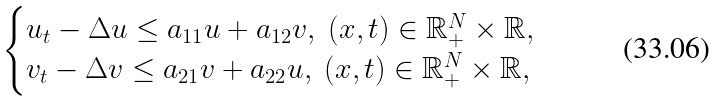Convert formula to latex. <formula><loc_0><loc_0><loc_500><loc_500>\begin{cases} u _ { t } - \Delta u \leq a _ { 1 1 } u + a _ { 1 2 } v , \ ( x , t ) \in \mathbb { R } _ { + } ^ { N } \times \mathbb { R } , \\ v _ { t } - \Delta v \leq a _ { 2 1 } v + a _ { 2 2 } u , \ ( x , t ) \in \mathbb { R } _ { + } ^ { N } \times \mathbb { R } , \end{cases}</formula> 